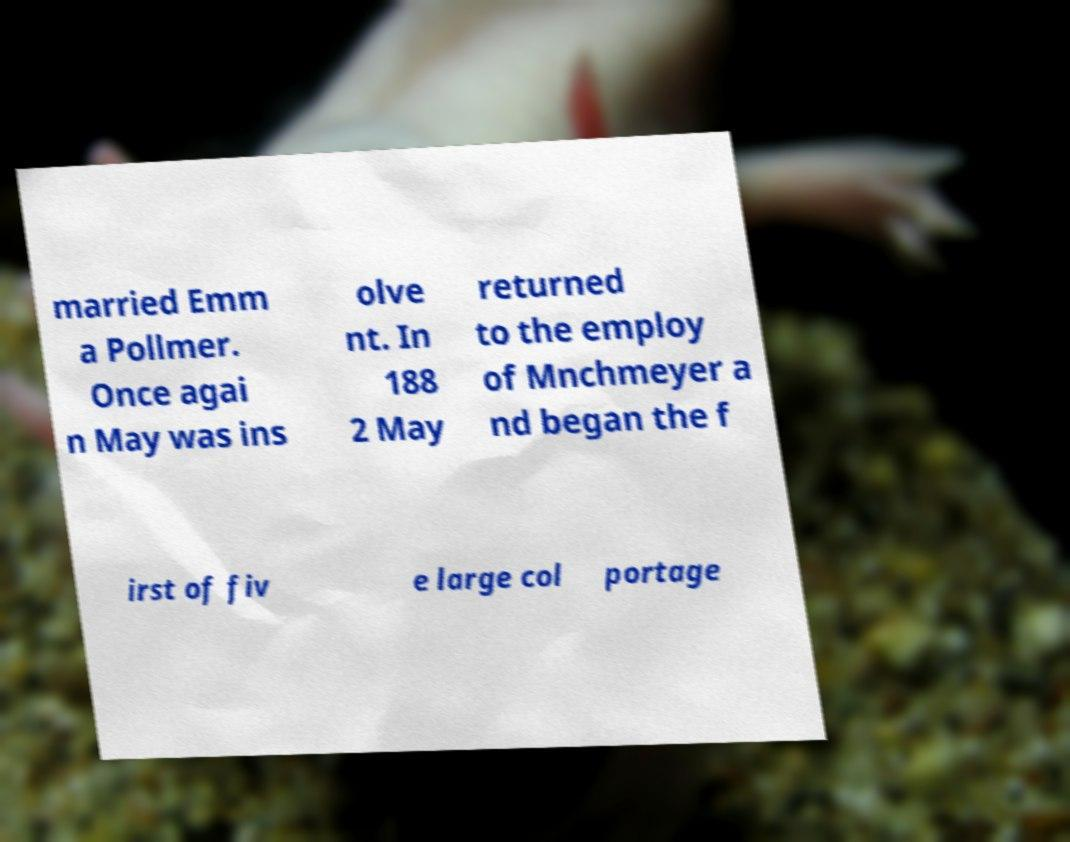There's text embedded in this image that I need extracted. Can you transcribe it verbatim? married Emm a Pollmer. Once agai n May was ins olve nt. In 188 2 May returned to the employ of Mnchmeyer a nd began the f irst of fiv e large col portage 